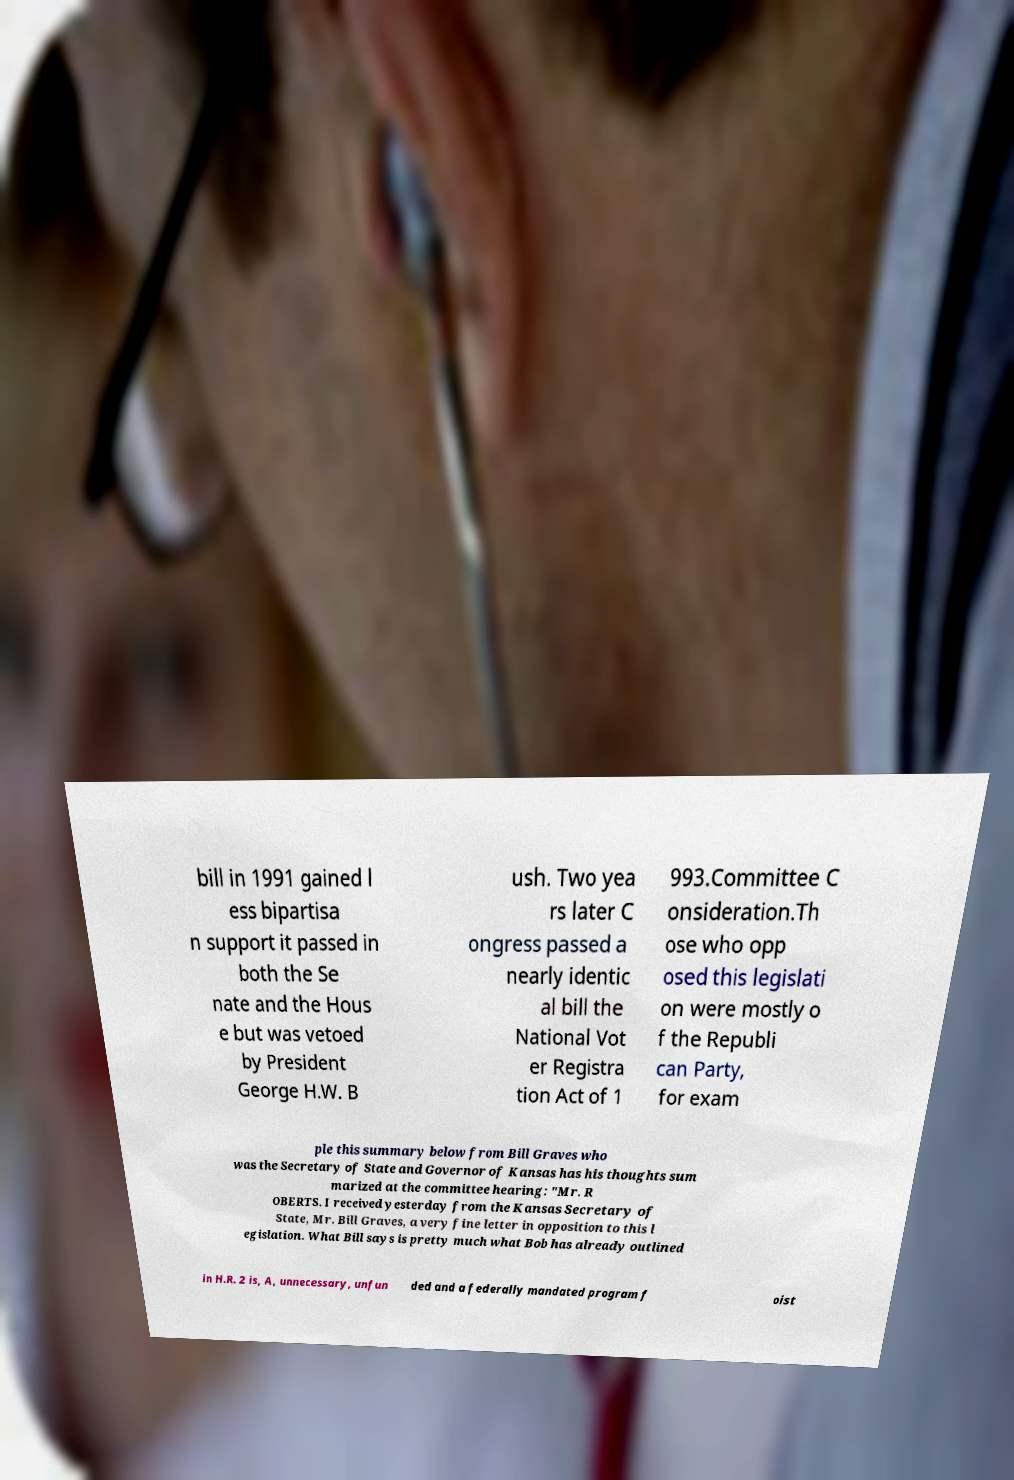Can you read and provide the text displayed in the image?This photo seems to have some interesting text. Can you extract and type it out for me? bill in 1991 gained l ess bipartisa n support it passed in both the Se nate and the Hous e but was vetoed by President George H.W. B ush. Two yea rs later C ongress passed a nearly identic al bill the National Vot er Registra tion Act of 1 993.Committee C onsideration.Th ose who opp osed this legislati on were mostly o f the Republi can Party, for exam ple this summary below from Bill Graves who was the Secretary of State and Governor of Kansas has his thoughts sum marized at the committee hearing: "Mr. R OBERTS. I received yesterday from the Kansas Secretary of State, Mr. Bill Graves, a very fine letter in opposition to this l egislation. What Bill says is pretty much what Bob has already outlined in H.R. 2 is, A, unnecessary, unfun ded and a federally mandated program f oist 